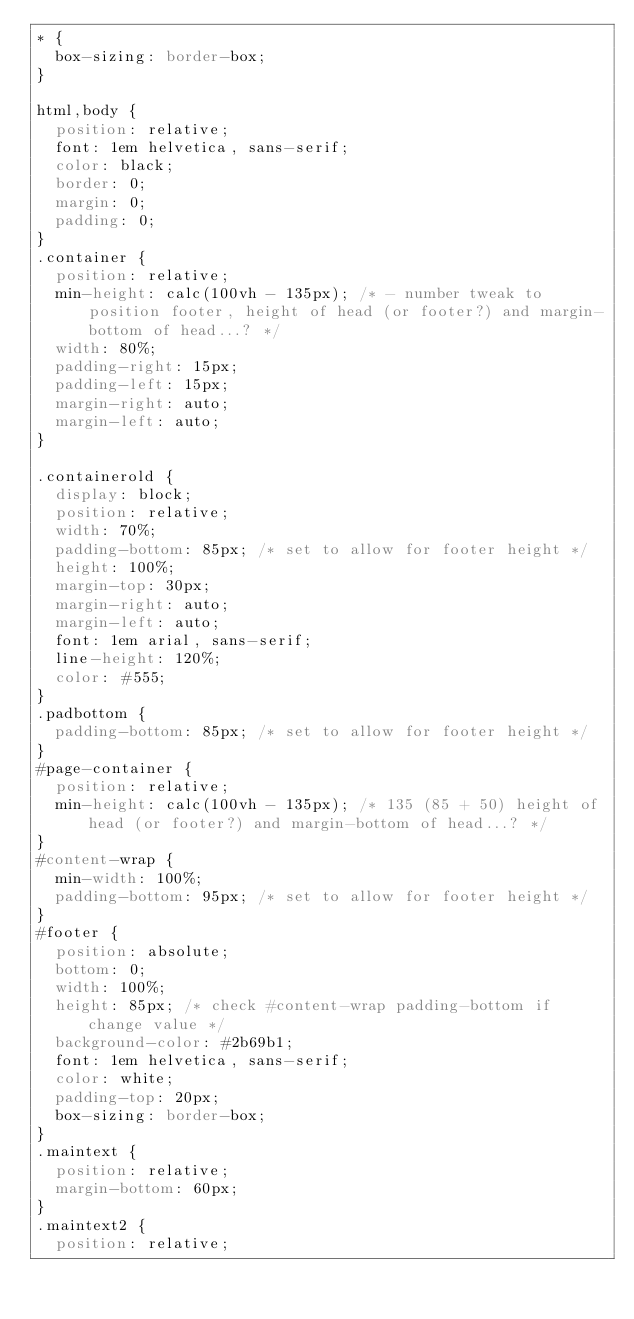<code> <loc_0><loc_0><loc_500><loc_500><_CSS_>* {
	box-sizing: border-box;
}

html,body {
	position: relative;
	font: 1em helvetica, sans-serif;
	color: black;
	border: 0;
	margin: 0;
	padding: 0;
}
.container {
	position: relative;
	min-height: calc(100vh - 135px); /* - number tweak to position footer, height of head (or footer?) and margin-bottom of head...? */
	width: 80%;
	padding-right: 15px;
	padding-left: 15px;
	margin-right: auto;
	margin-left: auto;
}

.containerold {
	display: block;
	position: relative;
	width: 70%;
	padding-bottom: 85px; /* set to allow for footer height */
	height: 100%;
	margin-top: 30px;
	margin-right: auto;
	margin-left: auto;
	font: 1em arial, sans-serif;
	line-height: 120%;
	color: #555;
}
.padbottom {
	padding-bottom: 85px; /* set to allow for footer height */
}
#page-container {
	position: relative;
	min-height: calc(100vh - 135px); /* 135 (85 + 50) height of head (or footer?) and margin-bottom of head...? */
}
#content-wrap {
	min-width: 100%;
	padding-bottom: 95px; /* set to allow for footer height */
}
#footer {
	position: absolute;
	bottom: 0;
	width: 100%;
	height: 85px; /* check #content-wrap padding-bottom if change value */
	background-color: #2b69b1;
	font: 1em helvetica, sans-serif;
	color: white;
	padding-top: 20px;
	box-sizing: border-box;
}
.maintext {
	position: relative;
	margin-bottom: 60px;
}
.maintext2 {
	position: relative;</code> 